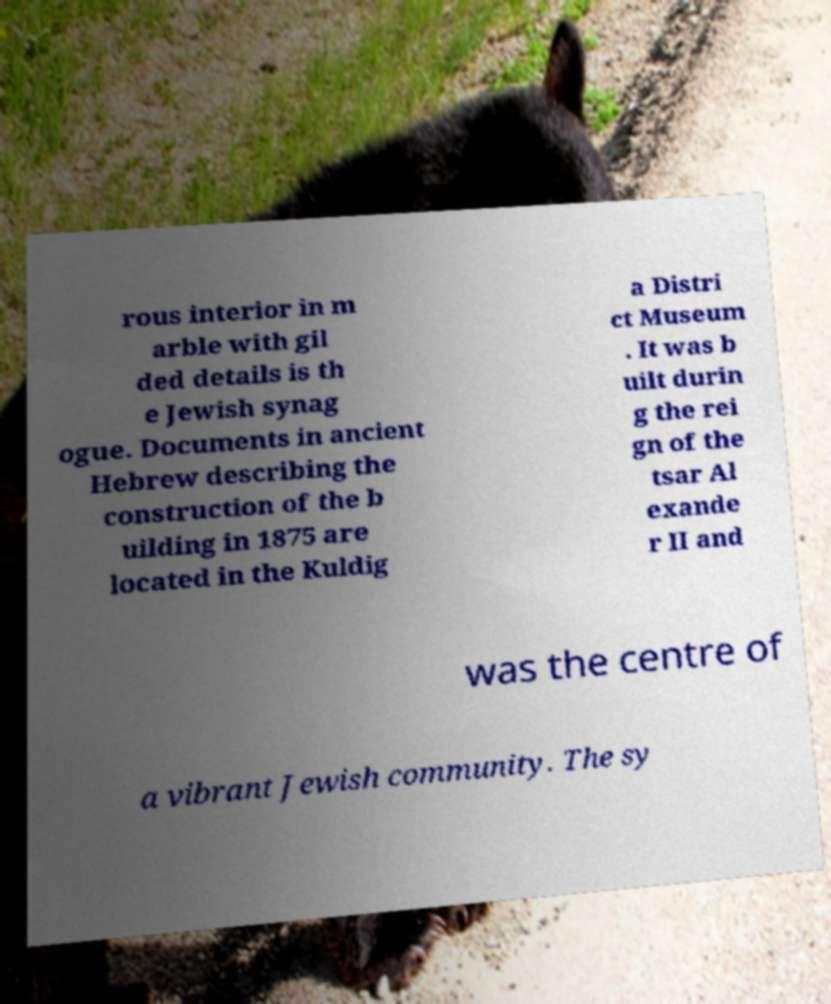I need the written content from this picture converted into text. Can you do that? rous interior in m arble with gil ded details is th e Jewish synag ogue. Documents in ancient Hebrew describing the construction of the b uilding in 1875 are located in the Kuldig a Distri ct Museum . It was b uilt durin g the rei gn of the tsar Al exande r II and was the centre of a vibrant Jewish community. The sy 